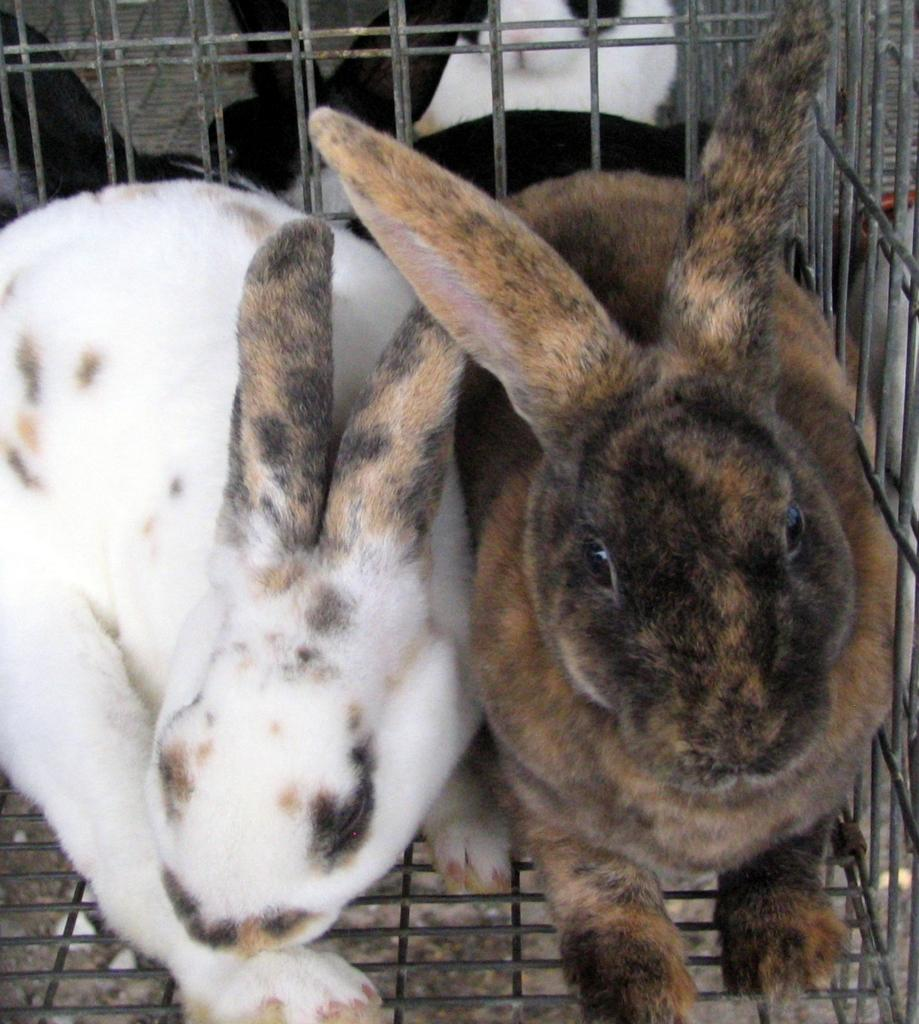How many rabbits are in the image? There are two rabbits in the image. Where are the rabbits located in the image? The rabbits are in a cage in the middle of the image. What colors are the rabbits? The rabbits are white and brown in color. What type of neck accessory is the rabbit wearing in the image? There is no neck accessory visible on the rabbits in the image. How does the umbrella protect the rabbits from the rain in the image? There is no umbrella present in the image, and therefore it cannot protect the rabbits from the rain. 